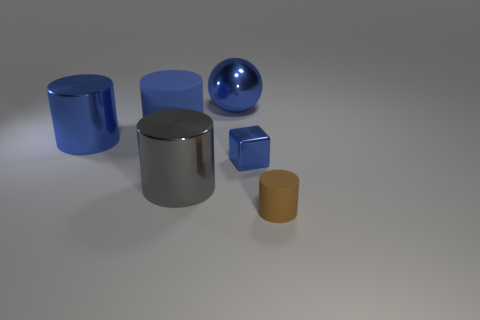What is the size of the gray object that is the same material as the large blue ball?
Offer a very short reply. Large. Is there any other thing of the same color as the big rubber thing?
Make the answer very short. Yes. There is a shiny cylinder in front of the metallic cylinder left of the rubber object left of the metallic ball; what color is it?
Your answer should be compact. Gray. Are there any other things that are the same material as the blue sphere?
Your answer should be very brief. Yes. There is a thing that is in front of the gray shiny cylinder; is it the same shape as the small shiny object?
Your answer should be compact. No. What is the tiny brown cylinder made of?
Ensure brevity in your answer.  Rubber. What is the shape of the big blue thing that is to the right of the gray cylinder in front of the big blue metallic object that is in front of the big blue ball?
Your answer should be very brief. Sphere. How many other things are the same shape as the small shiny thing?
Offer a very short reply. 0. There is a metal ball; is its color the same as the small thing that is to the left of the small matte cylinder?
Provide a succinct answer. Yes. How many big shiny balls are there?
Ensure brevity in your answer.  1. 